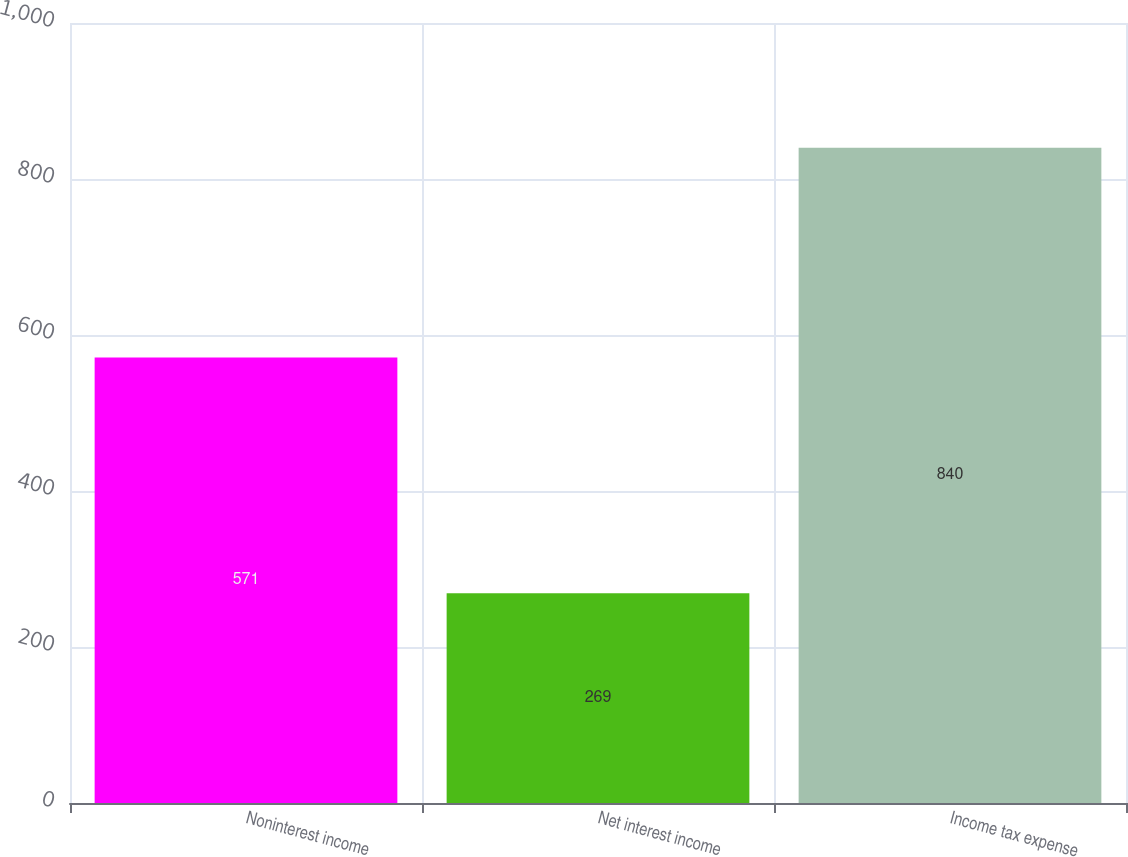Convert chart. <chart><loc_0><loc_0><loc_500><loc_500><bar_chart><fcel>Noninterest income<fcel>Net interest income<fcel>Income tax expense<nl><fcel>571<fcel>269<fcel>840<nl></chart> 